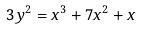<formula> <loc_0><loc_0><loc_500><loc_500>3 y ^ { 2 } = x ^ { 3 } + 7 x ^ { 2 } + x</formula> 